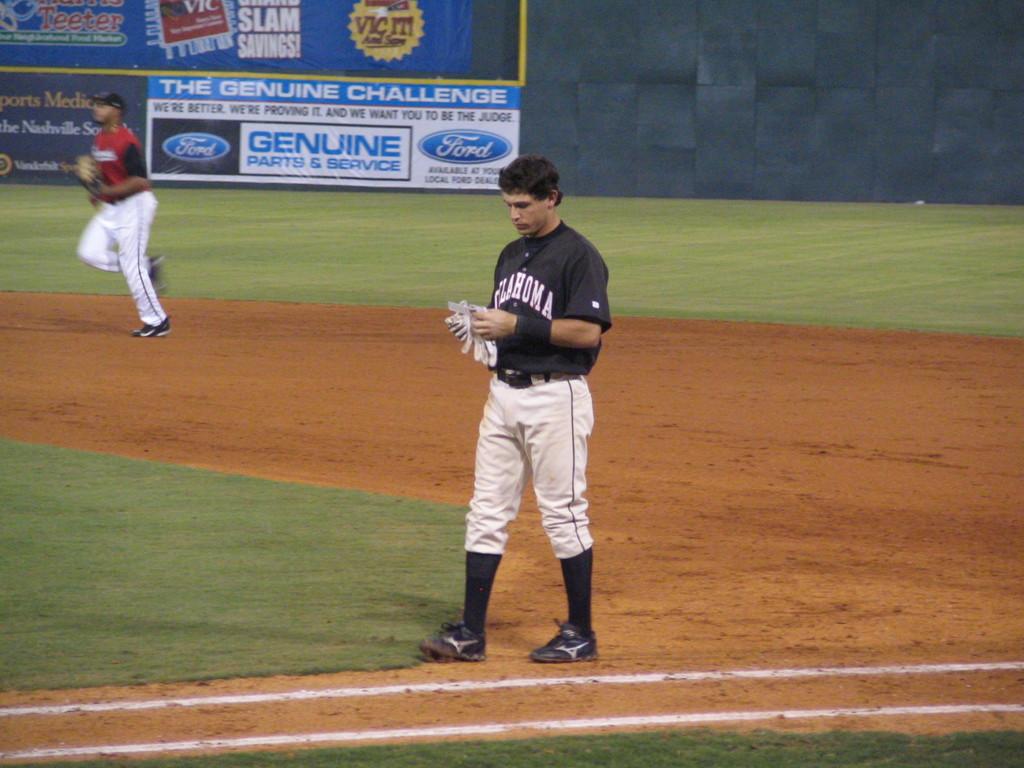What team does the player play for?
Give a very brief answer. Oklahoma. What car brand is on the billboard?
Keep it short and to the point. Ford. 